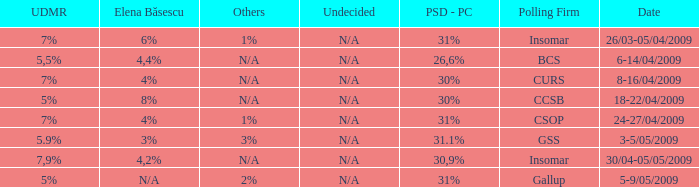What was the UDMR for 18-22/04/2009? 5%. 